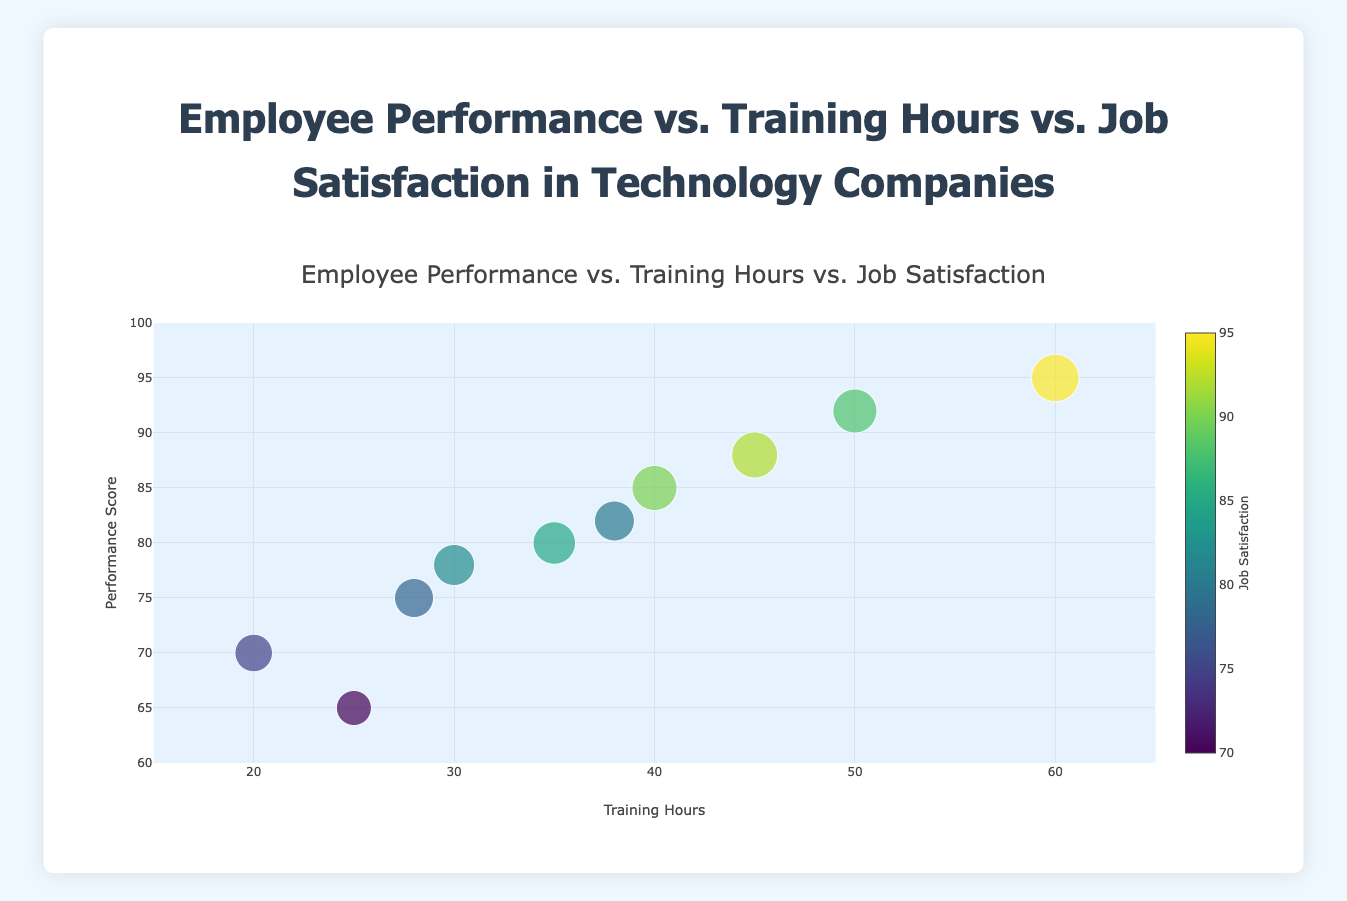What is the title of the chart? The title of the chart is located at the top and it summarizes the content of the chart.
Answer: Employee Performance vs. Training Hours vs. Job Satisfaction in Technology Companies How many employees are represented in the chart? Each data point on the chart represents one employee. By counting the data points, we can determine the number of employees.
Answer: 10 Which employee has the highest performance score? Look at the y-axis for the 'Performance Score' and find the data point with the highest value. Hover over this point to see the employee's name.
Answer: Hank Moore What is the job satisfaction level of the employee who has 45 training hours? Locate the data point with an x-value of 45 (Training Hours), and hover over it to see the job satisfaction level.
Answer: 92 Which two employees have the same job satisfaction level? Look for data points that share the same color intensity, as this represents job satisfaction. Crosscheck the exact job satisfaction values in the hover information.
Answer: Alice Smith and Eve Davis What is the average performance score of employees who received more than 40 training hours? Identify the performance scores of employees with training hours greater than 40. Add these scores and divide by the number of such employees. Employees are Carol Williams (92), Eve Davis (88), and Hank Moore (95). Calculate the average: (92 + 88 + 95) / 3 = 275 / 3
Answer: 91.67 Comparing Alice Smith and Bob Johnson, who has better job satisfaction, and by how much? Find the job satisfaction levels of Alice Smith and Bob Johnson. Compare these values: Alice Smith (90) and Bob Johnson (82). Subtract the smaller value from the larger value: 90 - 82 = 8
Answer: Alice Smith by 8 Which employee had the minimum training hours, and what is their performance score? Locate the data point with the lowest x-axis value (Training Hours). Hover over this point to determine the employee and their performance score.
Answer: David Brown with a score of 70 Is there a visible trend between training hours and job satisfaction? Observing the chart, check if an increase or decrease in training hours corresponds to changes in job satisfaction levels. Note the general direction of the data points in terms of color.
Answer: Yes, higher training hours tend to correlate with higher job satisfaction 